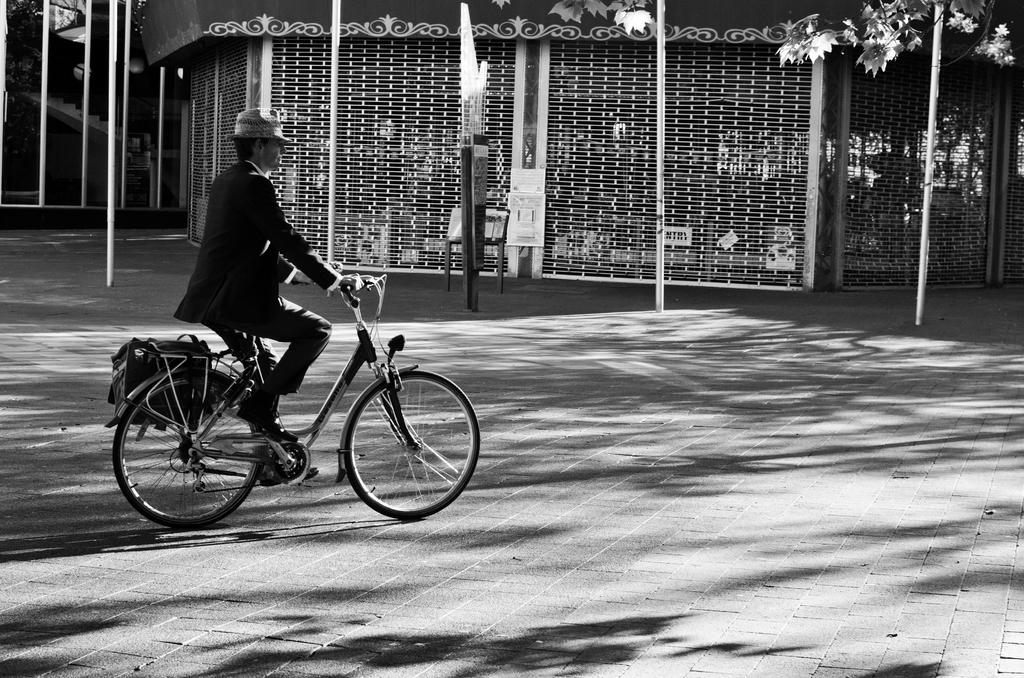What is the color scheme of the image? The image is black and white. What is the man in the image doing? The man is riding a bicycle. What is attached to the bicycle? There is a bag on the bicycle. What can be seen in the background of the image? There is a building in the image. What is the man wearing? The man is wearing a suit and a hat. What type of rhythm can be heard coming from the man's bicycle in the image? There is no sound or rhythm present in the image, as it is a still photograph. How many rabbits are visible in the image? There are no rabbits present in the image. 